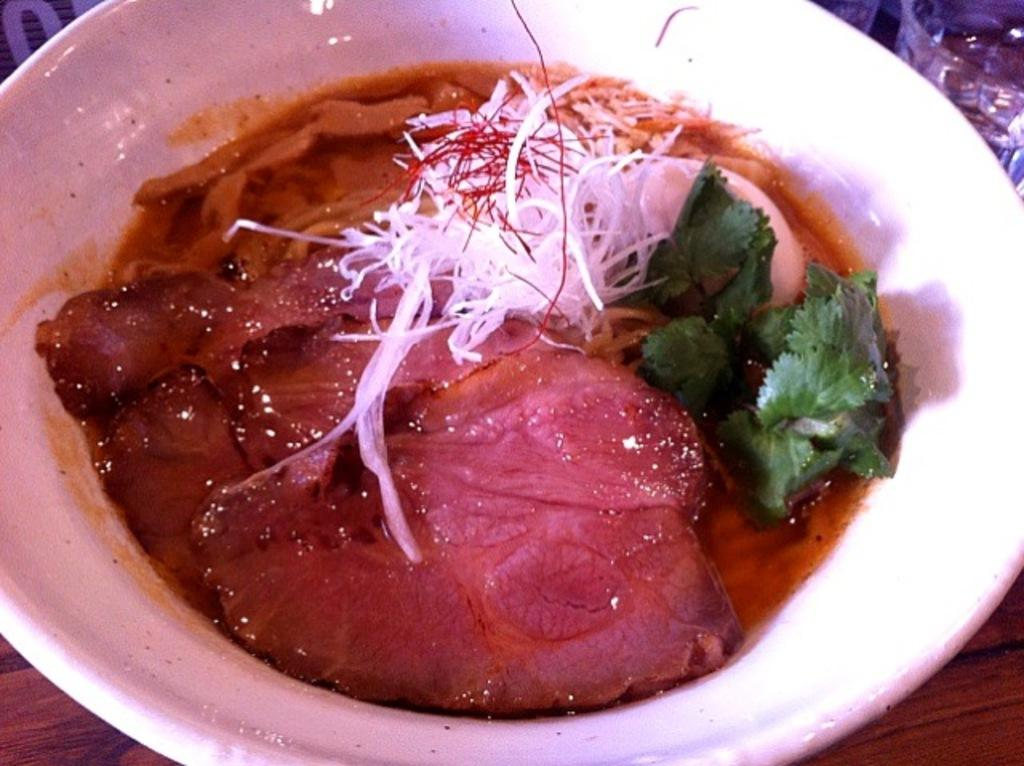What type of food is in the bowl in the image? The food in the bowl includes egg and cilantro. Where is the bowl of food located? The bowl is on a table. What other item is on the table in the image? There is a water glass on the side of the table. How does the group of people react to the earthquake in the image? There is no group of people or earthquake present in the image; it only shows a bowl of food with egg and cilantro on a table with a water glass. 